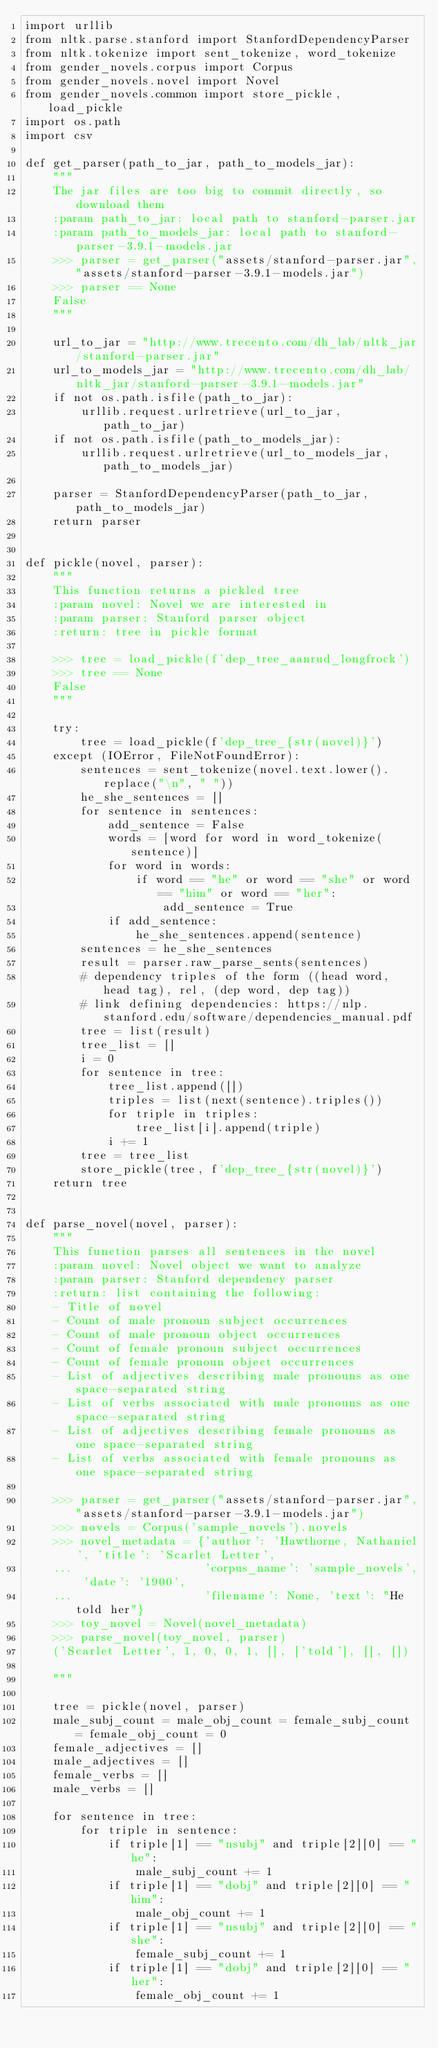Convert code to text. <code><loc_0><loc_0><loc_500><loc_500><_Python_>import urllib
from nltk.parse.stanford import StanfordDependencyParser
from nltk.tokenize import sent_tokenize, word_tokenize
from gender_novels.corpus import Corpus
from gender_novels.novel import Novel
from gender_novels.common import store_pickle, load_pickle
import os.path
import csv

def get_parser(path_to_jar, path_to_models_jar):
    """
    The jar files are too big to commit directly, so download them
    :param path_to_jar: local path to stanford-parser.jar
    :param path_to_models_jar: local path to stanford-parser-3.9.1-models.jar
    >>> parser = get_parser("assets/stanford-parser.jar","assets/stanford-parser-3.9.1-models.jar")
    >>> parser == None
    False
    """

    url_to_jar = "http://www.trecento.com/dh_lab/nltk_jar/stanford-parser.jar"
    url_to_models_jar = "http://www.trecento.com/dh_lab/nltk_jar/stanford-parser-3.9.1-models.jar"
    if not os.path.isfile(path_to_jar):
        urllib.request.urlretrieve(url_to_jar, path_to_jar)
    if not os.path.isfile(path_to_models_jar):
        urllib.request.urlretrieve(url_to_models_jar, path_to_models_jar)

    parser = StanfordDependencyParser(path_to_jar, path_to_models_jar)
    return parser


def pickle(novel, parser):
    """
    This function returns a pickled tree
    :param novel: Novel we are interested in
    :param parser: Stanford parser object
    :return: tree in pickle format

    >>> tree = load_pickle(f'dep_tree_aanrud_longfrock')
    >>> tree == None
    False
    """

    try:
        tree = load_pickle(f'dep_tree_{str(novel)}')
    except (IOError, FileNotFoundError):
        sentences = sent_tokenize(novel.text.lower().replace("\n", " "))
        he_she_sentences = []
        for sentence in sentences:
            add_sentence = False
            words = [word for word in word_tokenize(sentence)]
            for word in words:
                if word == "he" or word == "she" or word == "him" or word == "her":
                    add_sentence = True
            if add_sentence:
                he_she_sentences.append(sentence)
        sentences = he_she_sentences
        result = parser.raw_parse_sents(sentences)
        # dependency triples of the form ((head word, head tag), rel, (dep word, dep tag))
        # link defining dependencies: https://nlp.stanford.edu/software/dependencies_manual.pdf
        tree = list(result)
        tree_list = []
        i = 0
        for sentence in tree:
            tree_list.append([])
            triples = list(next(sentence).triples())
            for triple in triples:
                tree_list[i].append(triple)
            i += 1
        tree = tree_list
        store_pickle(tree, f'dep_tree_{str(novel)}')
    return tree


def parse_novel(novel, parser):
    """
    This function parses all sentences in the novel
    :param novel: Novel object we want to analyze
    :param parser: Stanford dependency parser
    :return: list containing the following:
    - Title of novel
    - Count of male pronoun subject occurrences
    - Count of male pronoun object occurrences
    - Count of female pronoun subject occurrences
    - Count of female pronoun object occurrences
    - List of adjectives describing male pronouns as one space-separated string
    - List of verbs associated with male pronouns as one space-separated string
    - List of adjectives describing female pronouns as one space-separated string
    - List of verbs associated with female pronouns as one space-separated string

    >>> parser = get_parser("assets/stanford-parser.jar","assets/stanford-parser-3.9.1-models.jar")
    >>> novels = Corpus('sample_novels').novels
    >>> novel_metadata = {'author': 'Hawthorne, Nathaniel', 'title': 'Scarlet Letter',
    ...                   'corpus_name': 'sample_novels', 'date': '1900',
    ...                   'filename': None, 'text': "He told her"}
    >>> toy_novel = Novel(novel_metadata)
    >>> parse_novel(toy_novel, parser)
    ('Scarlet Letter', 1, 0, 0, 1, [], ['told'], [], [])

    """

    tree = pickle(novel, parser)
    male_subj_count = male_obj_count = female_subj_count = female_obj_count = 0
    female_adjectives = []
    male_adjectives = []
    female_verbs = []
    male_verbs = []

    for sentence in tree:
        for triple in sentence:
            if triple[1] == "nsubj" and triple[2][0] == "he":
                male_subj_count += 1
            if triple[1] == "dobj" and triple[2][0] == "him":
                male_obj_count += 1
            if triple[1] == "nsubj" and triple[2][0] == "she":
                female_subj_count += 1
            if triple[1] == "dobj" and triple[2][0] == "her":
                female_obj_count += 1</code> 